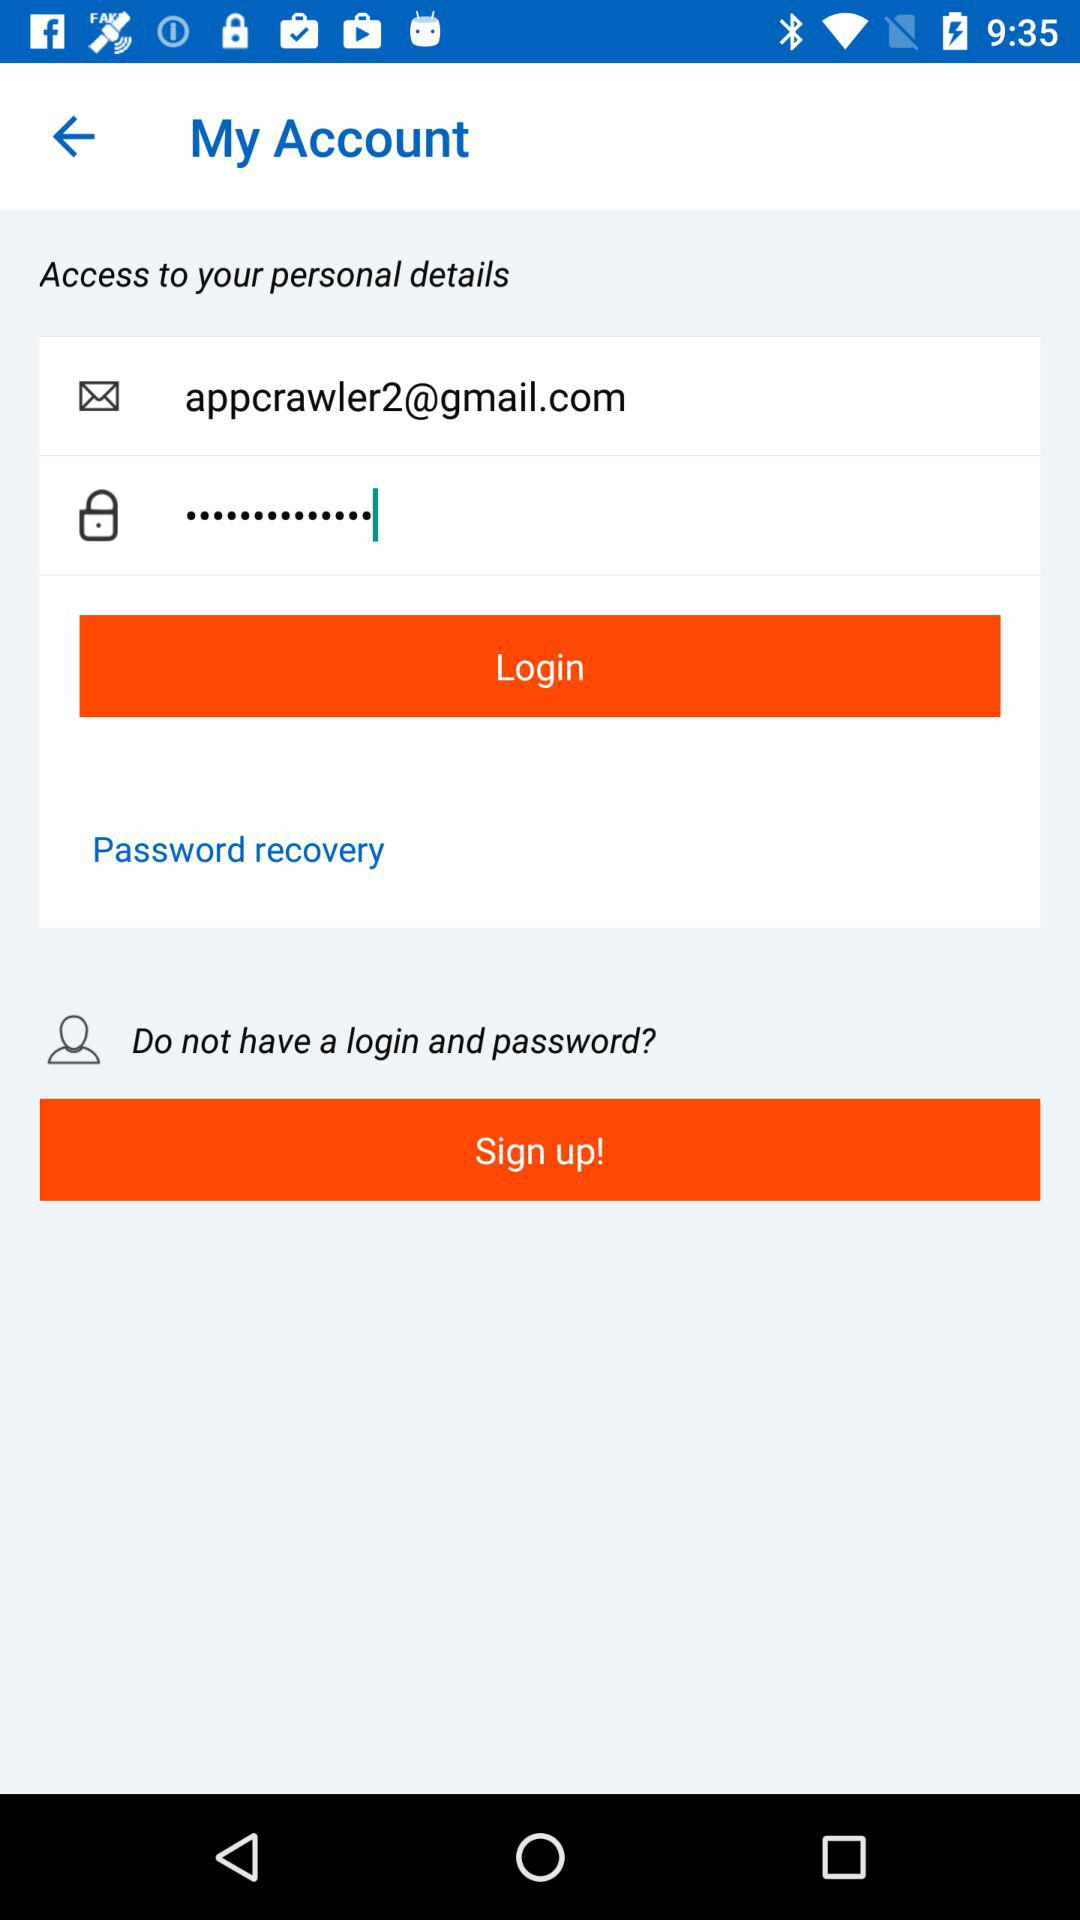How many fields are there in the login form?
Answer the question using a single word or phrase. 2 